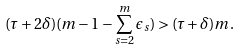Convert formula to latex. <formula><loc_0><loc_0><loc_500><loc_500>( \tau + 2 \delta ) ( m - 1 - \sum _ { s = 2 } ^ { m } \epsilon _ { s } ) > ( \tau + \delta ) m .</formula> 